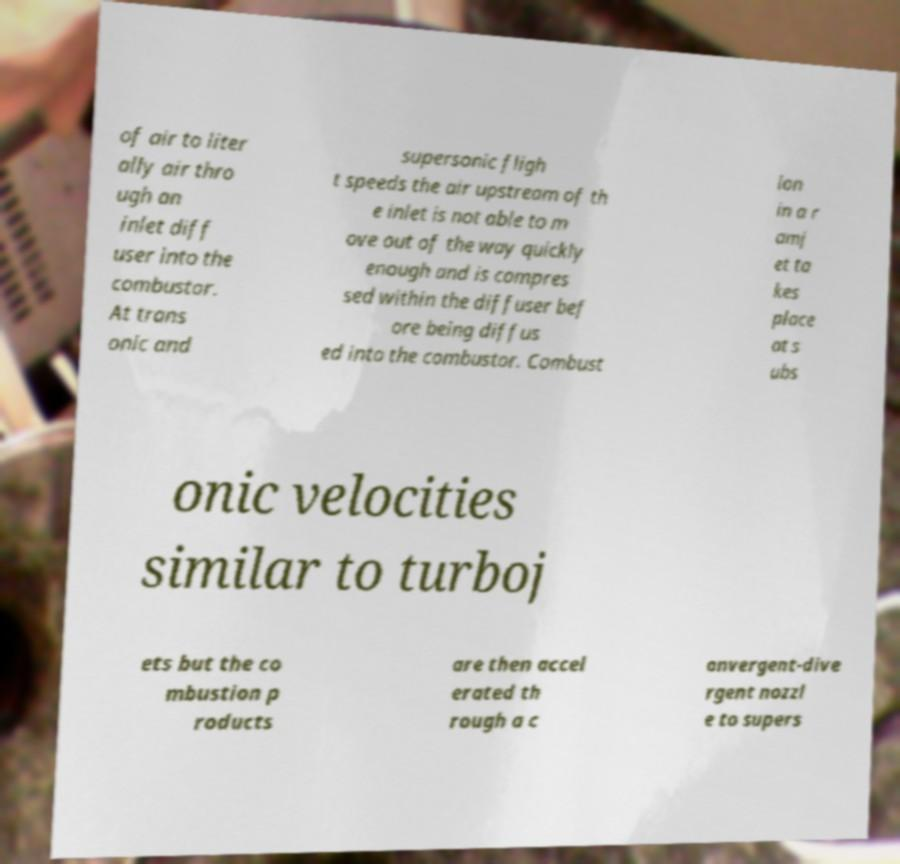Please read and relay the text visible in this image. What does it say? of air to liter ally air thro ugh an inlet diff user into the combustor. At trans onic and supersonic fligh t speeds the air upstream of th e inlet is not able to m ove out of the way quickly enough and is compres sed within the diffuser bef ore being diffus ed into the combustor. Combust ion in a r amj et ta kes place at s ubs onic velocities similar to turboj ets but the co mbustion p roducts are then accel erated th rough a c onvergent-dive rgent nozzl e to supers 